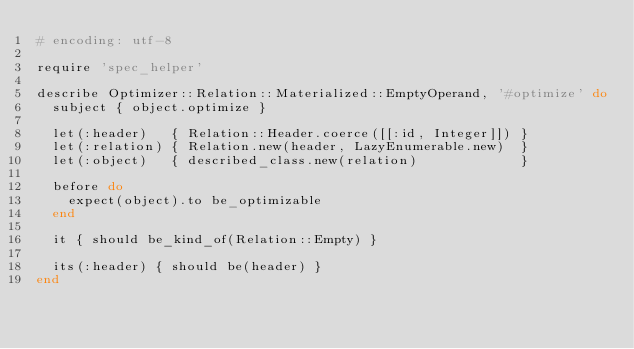<code> <loc_0><loc_0><loc_500><loc_500><_Ruby_># encoding: utf-8

require 'spec_helper'

describe Optimizer::Relation::Materialized::EmptyOperand, '#optimize' do
  subject { object.optimize }

  let(:header)   { Relation::Header.coerce([[:id, Integer]]) }
  let(:relation) { Relation.new(header, LazyEnumerable.new)  }
  let(:object)   { described_class.new(relation)             }

  before do
    expect(object).to be_optimizable
  end

  it { should be_kind_of(Relation::Empty) }

  its(:header) { should be(header) }
end
</code> 